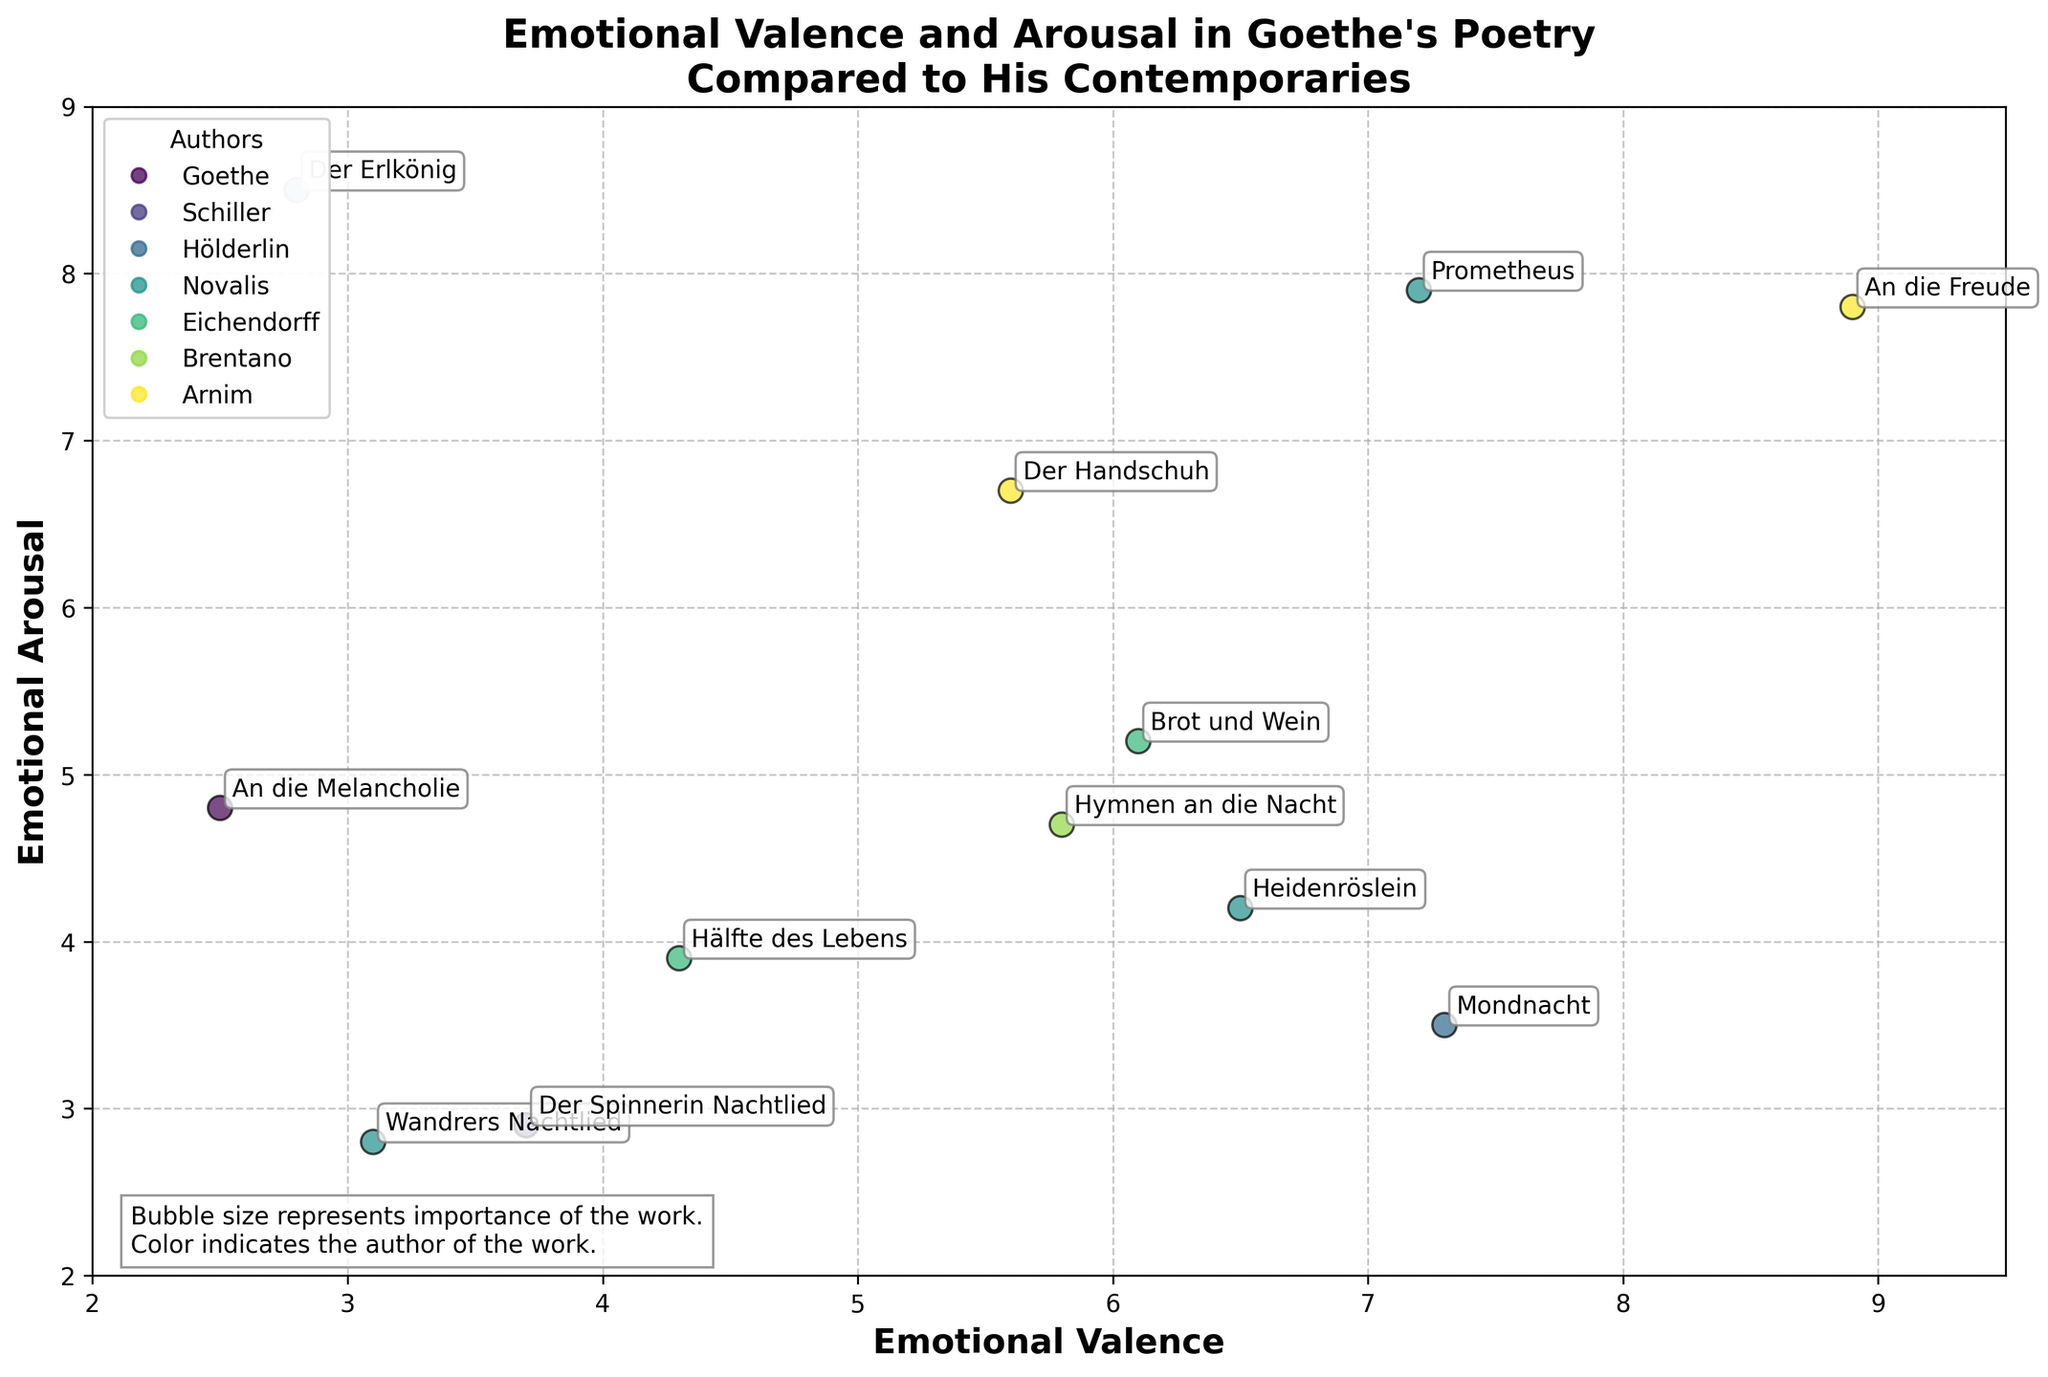What is the title of the figure? The title is shown at the top of the plot in bold font. It reads "Emotional Valence and Arousal in Goethe's Poetry Compared to His Contemporaries."
Answer: Emotional Valence and Arousal in Goethe's Poetry Compared to His Contemporaries Which work by Goethe has the highest emotional arousal? The figure shows the works plotted with their arousal scores along the y-axis. Among Goethe's works, "Der Erlkönig" has the highest arousal score.
Answer: Der Erlkönig How many data points are there for Goethe in the plot? Each data point represents a work by an author. By looking at the legend and the names attached to the points in the figure, you count four works by Goethe.
Answer: 4 Which work has the highest emotional valence overall? The data points are plotted with their valence scores along the x-axis. "An die Freude" by Schiller has the highest valence score of 8.9.
Answer: An die Freude Which author's works have the lowest average emotional valence? Calculate the average valence for each author by adding the valence scores of their works and dividing by the number of works. Hölderlin has an average valence of (4.3 + 6.1) / 2 = 5.2, which is lower than Goethe (4.9), Schiller (7.25), Novalis (5.8), Eichendorff (7.3), Brentano (3.7), and Arnim (2.5).
Answer: Arnim Between "Heidenröslein" by Goethe and "Mondnacht" by Eichendorff, which has lower emotional arousal? Compare the arousal values of the two works on the y-axis. "Heidenröslein" has an arousal of 4.2, while "Mondnacht" has a lower arousal of 3.5.
Answer: Mondnacht What is the emotional valence and arousal for "Prometheus" by Goethe? Locate "Prometheus" on the scatter plot and read its coordinates. The plot shows a valence of 7.2 and an arousal of 7.9 for "Prometheus".
Answer: 7.2, 7.9 Which author's work is described in the explanatory text as having a high importance with a big bubble size? The explanatory text mentions bubble size represents the importance of the work, and high importance corresponds to a larger bubble size.
Answer: None (This information is not provided in the figure) For the work "Wandrers Nachtlied" by Goethe, what are its emotional valence and arousal scores? Find "Wandrers Nachtlied" on the scatter plot and read its coordinates. The plot shows a valence of 3.1 and an arousal of 2.8 for "Wandrers Nachtlied".
Answer: 3.1, 2.8 